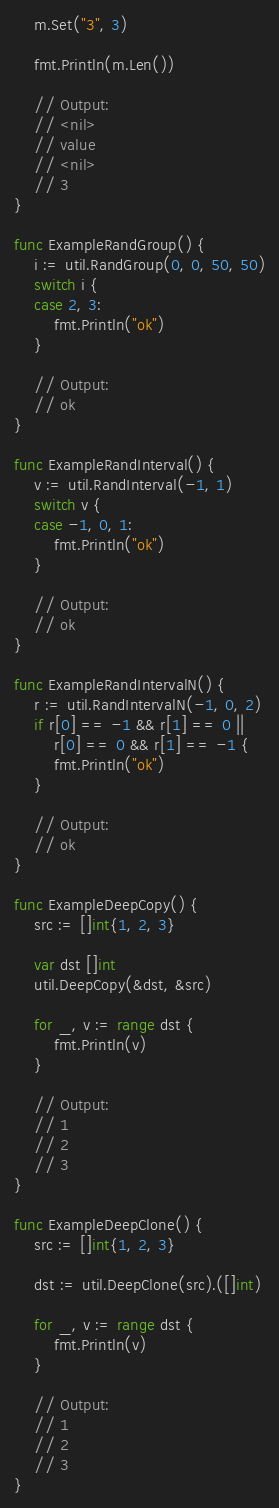Convert code to text. <code><loc_0><loc_0><loc_500><loc_500><_Go_>	m.Set("3", 3)

	fmt.Println(m.Len())

	// Output:
	// <nil>
	// value
	// <nil>
	// 3
}

func ExampleRandGroup() {
	i := util.RandGroup(0, 0, 50, 50)
	switch i {
	case 2, 3:
		fmt.Println("ok")
	}

	// Output:
	// ok
}

func ExampleRandInterval() {
	v := util.RandInterval(-1, 1)
	switch v {
	case -1, 0, 1:
		fmt.Println("ok")
	}

	// Output:
	// ok
}

func ExampleRandIntervalN() {
	r := util.RandIntervalN(-1, 0, 2)
	if r[0] == -1 && r[1] == 0 ||
		r[0] == 0 && r[1] == -1 {
		fmt.Println("ok")
	}

	// Output:
	// ok
}

func ExampleDeepCopy() {
	src := []int{1, 2, 3}

	var dst []int
	util.DeepCopy(&dst, &src)

	for _, v := range dst {
		fmt.Println(v)
	}

	// Output:
	// 1
	// 2
	// 3
}

func ExampleDeepClone() {
	src := []int{1, 2, 3}

	dst := util.DeepClone(src).([]int)

	for _, v := range dst {
		fmt.Println(v)
	}

	// Output:
	// 1
	// 2
	// 3
}
</code> 